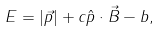<formula> <loc_0><loc_0><loc_500><loc_500>E = | { \vec { p } } | + c { \hat { p } } \cdot { \vec { B } } - b ,</formula> 